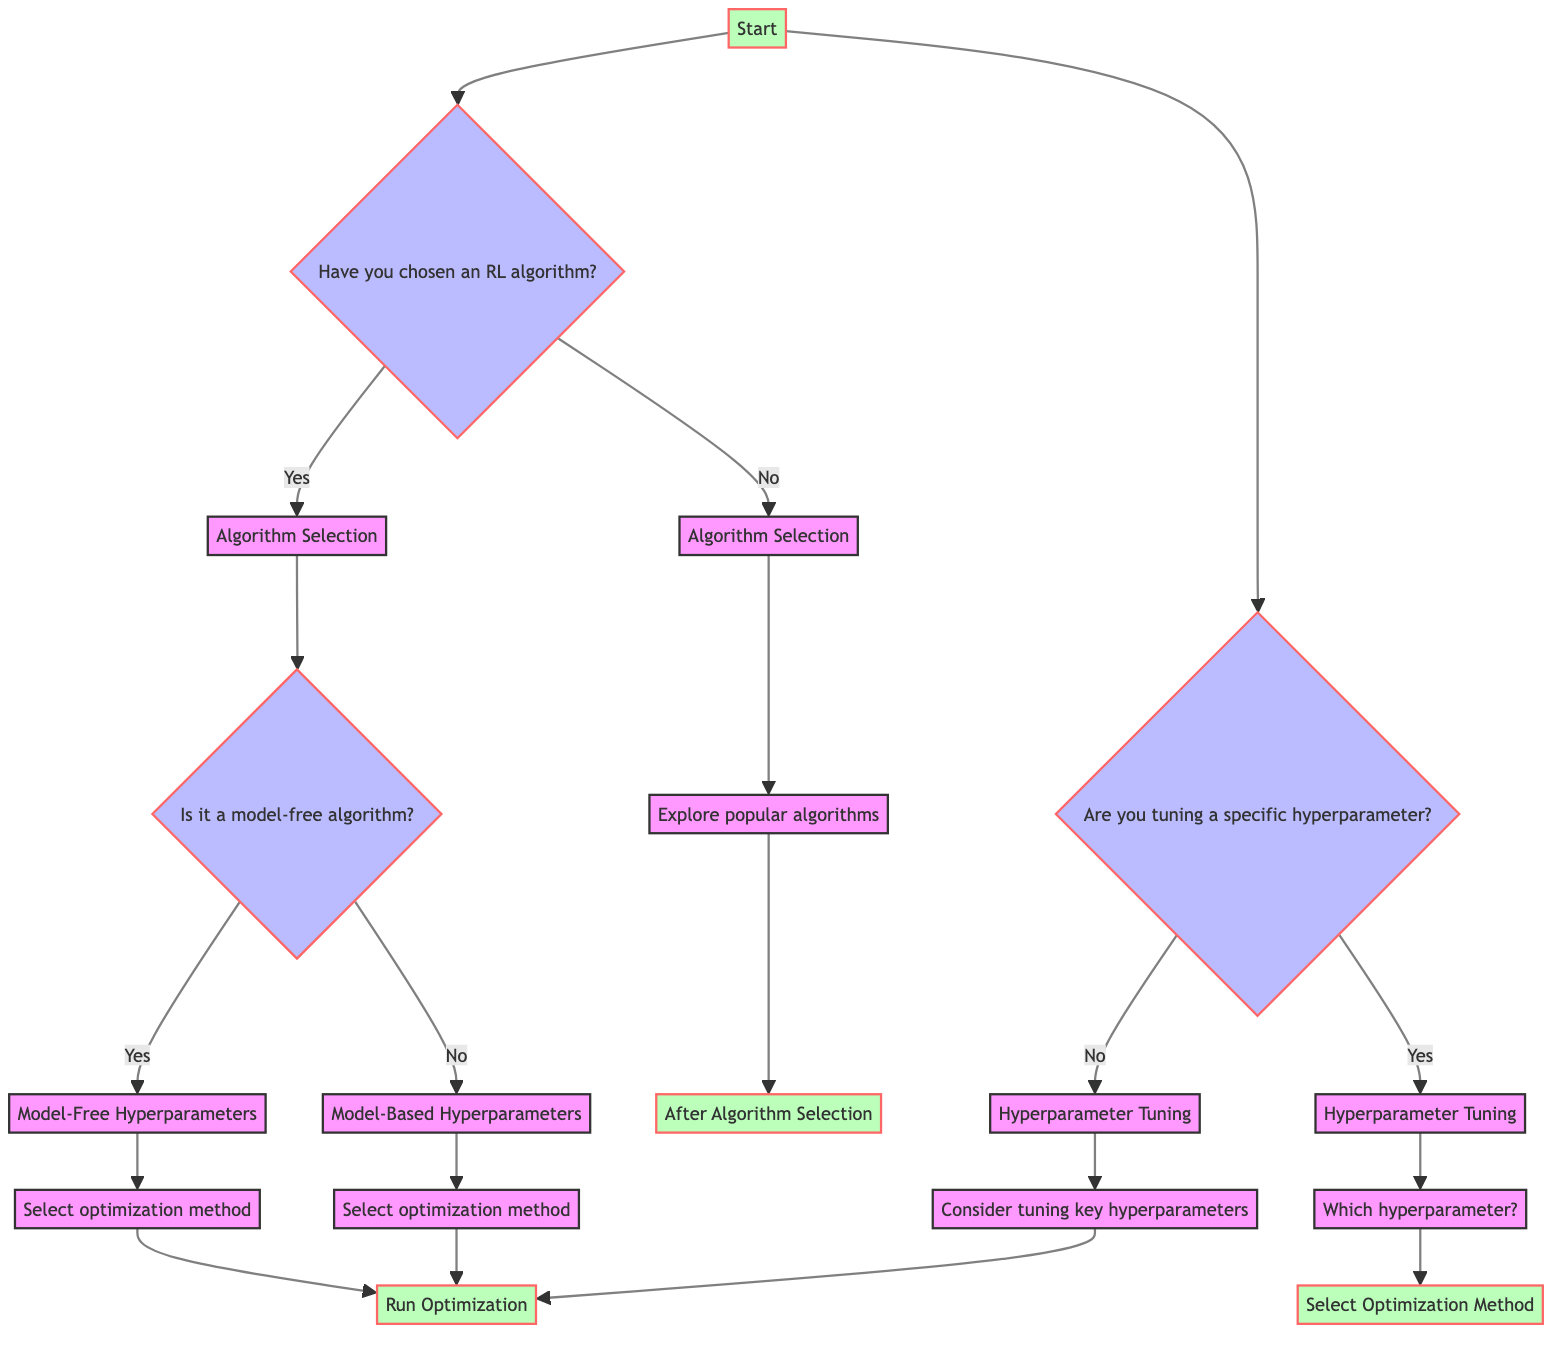What is the initial node of the decision tree? The initial node of the decision tree is labeled "Start." This is the starting point from which all decisions flow in the diagram.
Answer: Start How many options are presented at the first decision node? The first decision node presents two options: one related to choosing an RL algorithm and another regarding tuning a specific hyperparameter. This clearly indicates the paths the user can take.
Answer: 2 What is the first node after selecting a specific RL algorithm? After selecting an RL algorithm, the first node is "Algorithm Selection." This node directs the user based on whether they have a model-free or model-based algorithm, indicating the next steps based on their choice.
Answer: Algorithm Selection What are the three optimization methods available for hyperparameter tuning? The diagram lists three optimization methods: Grid Search, Random Search, and Bayesian Optimization. These methods are options available at both the model-free and model-based hyperparameter nodes.
Answer: Grid Search, Random Search, Bayesian Optimization If a user has not chosen an RL algorithm, what will they explore? If the user has not chosen an RL algorithm, they will explore popular algorithms. This step provides guidance on which reinforcement learning algorithms they could potentially choose.
Answer: Popular algorithms Which hyperparameter options are considered for tuning if no specific hyperparameter is chosen? If no specific hyperparameter is selected, key hyperparameters considered for tuning are Learning Rate, Discount Factor (Gamma), and Exploration Rate. This node serves as a suggestion for significant hyperparameters to optimize.
Answer: Learning Rate, Discount Factor (Gamma), Exploration Rate What follows after selecting an optimization method in the model-free hyperparameters? After selecting an optimization method in the model-free hyperparameters, the next action is to "Run Optimization." This indicates the conclusion of the tuning selection process for this path in the decision tree.
Answer: Run Optimization Which node does the 'Explore popular algorithms' lead to? The 'Explore popular algorithms' node leads to the 'After Algorithm Selection' node. This indicates the flow after the user has considered popular algorithms.
Answer: After Algorithm Selection How does the decision tree branch for a model-free versus model-based algorithm? The decision tree branches from the 'Algorithm Selection' node into two paths: one for model-free algorithms and another for model-based algorithms, each leading to their respective hyperparameter tuning methods.
Answer: Two paths 